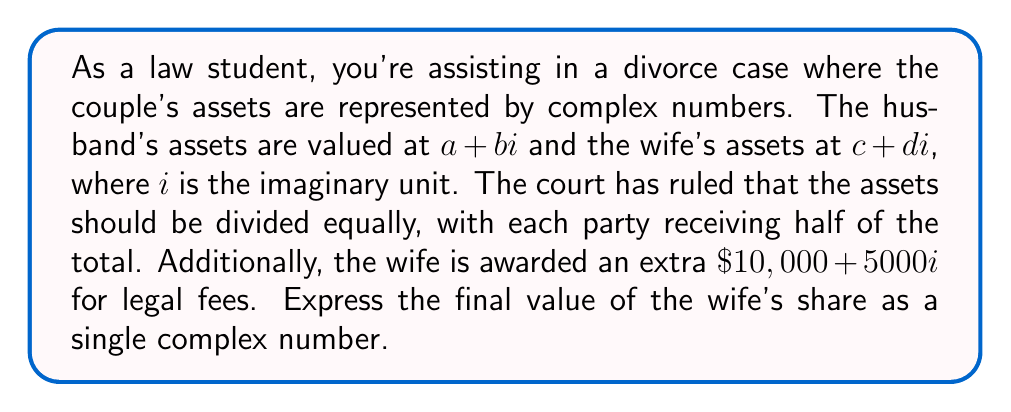Can you answer this question? To solve this problem, we'll follow these steps:

1. Calculate the total assets:
   Total assets = Husband's assets + Wife's assets
   $$(a + bi) + (c + di) = (a + c) + (b + d)i$$

2. Divide the total assets by 2 to get each party's equal share:
   $$\frac{(a + c) + (b + d)i}{2} = \frac{a + c}{2} + \frac{b + d}{2}i$$

3. Add the extra amount awarded to the wife for legal fees:
   Wife's final share = Equal share + Legal fees
   $$\left(\frac{a + c}{2} + \frac{b + d}{2}i\right) + (10000 + 5000i)$$

4. Combine like terms:
   $$\left(\frac{a + c}{2} + 10000\right) + \left(\frac{b + d}{2} + 5000\right)i$$

The final expression represents the wife's share as a single complex number.
Answer: The wife's final share is:
$$\left(\frac{a + c}{2} + 10000\right) + \left(\frac{b + d}{2} + 5000\right)i$$ 